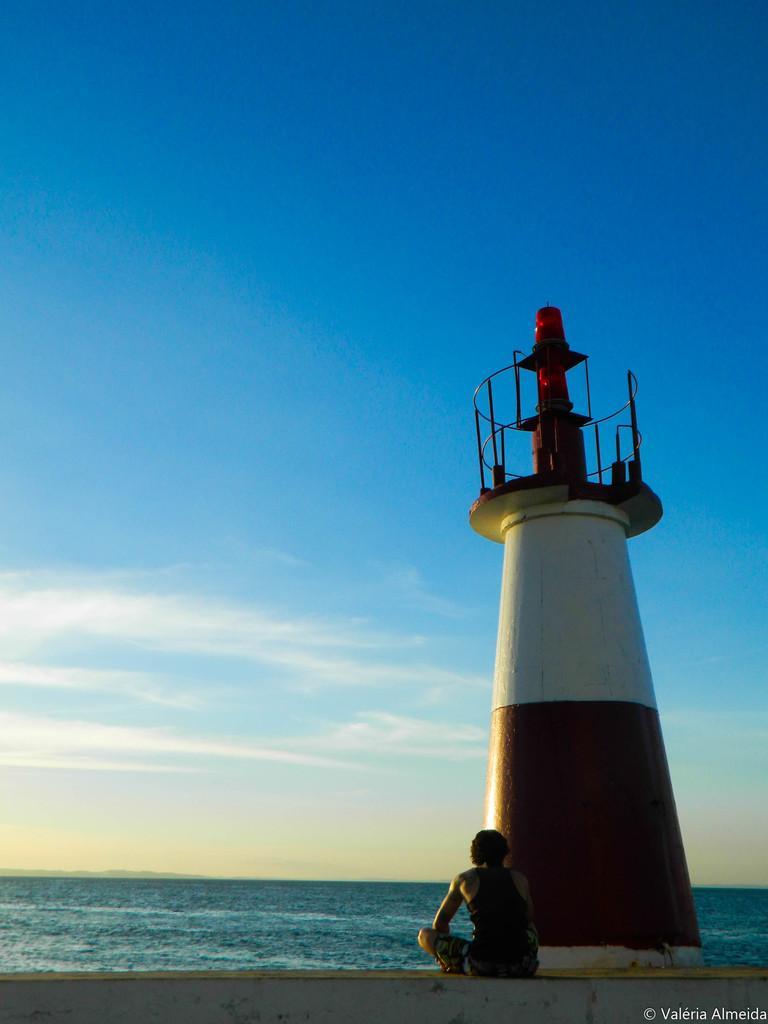Describe this image in one or two sentences. In this image I can see a lighthouse and here I can see a person is sitting. In the background I can see water, clouds and the sky. 